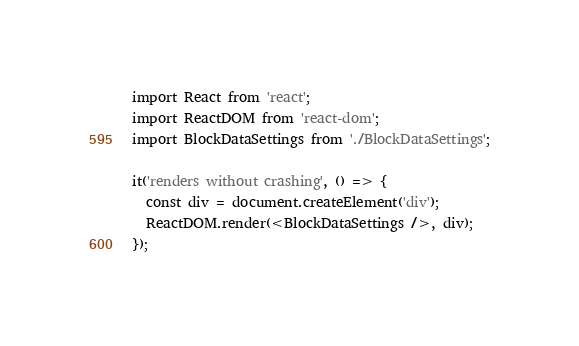Convert code to text. <code><loc_0><loc_0><loc_500><loc_500><_JavaScript_>import React from 'react';
import ReactDOM from 'react-dom';
import BlockDataSettings from './BlockDataSettings';

it('renders without crashing', () => {
  const div = document.createElement('div');
  ReactDOM.render(<BlockDataSettings />, div);
});
</code> 